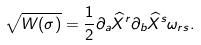<formula> <loc_0><loc_0><loc_500><loc_500>\sqrt { W ( \sigma ) } = \frac { 1 } { 2 } \partial _ { a } \widehat { X } ^ { r } \partial _ { b } \widehat { X } ^ { s } \omega _ { r s } .</formula> 